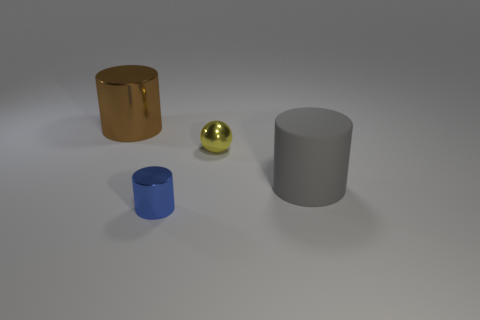Add 1 brown shiny objects. How many objects exist? 5 Subtract all cylinders. How many objects are left? 1 Add 2 small things. How many small things are left? 4 Add 4 red rubber objects. How many red rubber objects exist? 4 Subtract 0 gray blocks. How many objects are left? 4 Subtract all gray cylinders. Subtract all blue metal cylinders. How many objects are left? 2 